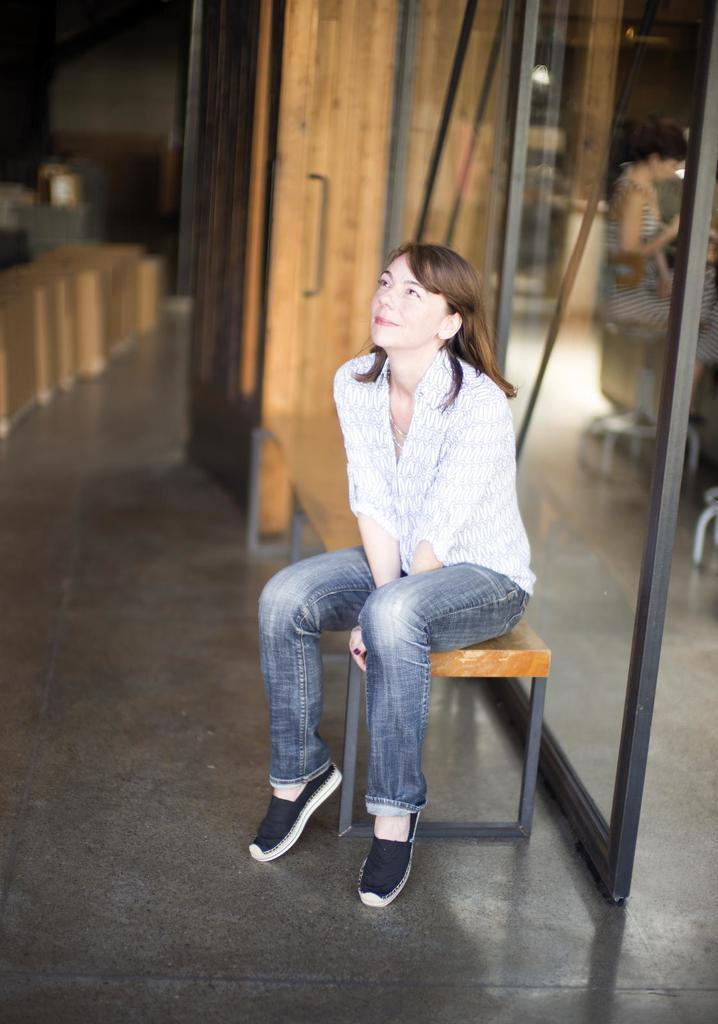What is the woman in the image doing? The woman is sitting on a stool in the image. What type of material is used for the windows in the image? The windows in the image are made of glass. Can you describe the people present in the image? There are people present in the image, but their specific actions or characteristics are not mentioned in the provided facts. How would you describe the background of the image? The background of the image is blurred. What type of nail is the servant using to fix the window in the image? There is no servant or nail present in the image, and therefore no such activity can be observed. 